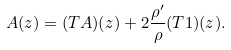<formula> <loc_0><loc_0><loc_500><loc_500>A ( z ) = ( T A ) ( z ) + 2 \frac { \rho ^ { \prime } } { \rho } ( T 1 ) ( z ) .</formula> 